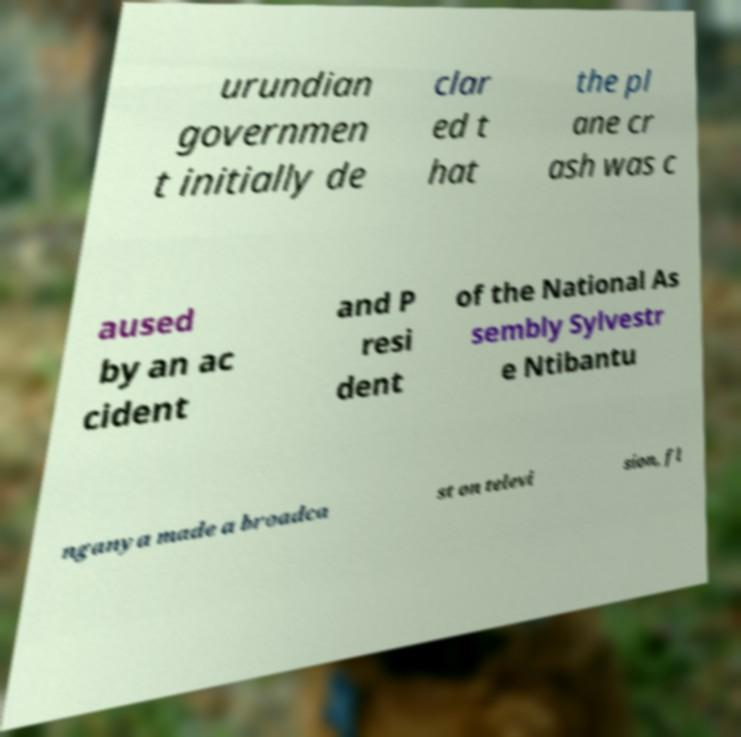I need the written content from this picture converted into text. Can you do that? urundian governmen t initially de clar ed t hat the pl ane cr ash was c aused by an ac cident and P resi dent of the National As sembly Sylvestr e Ntibantu nganya made a broadca st on televi sion, fl 